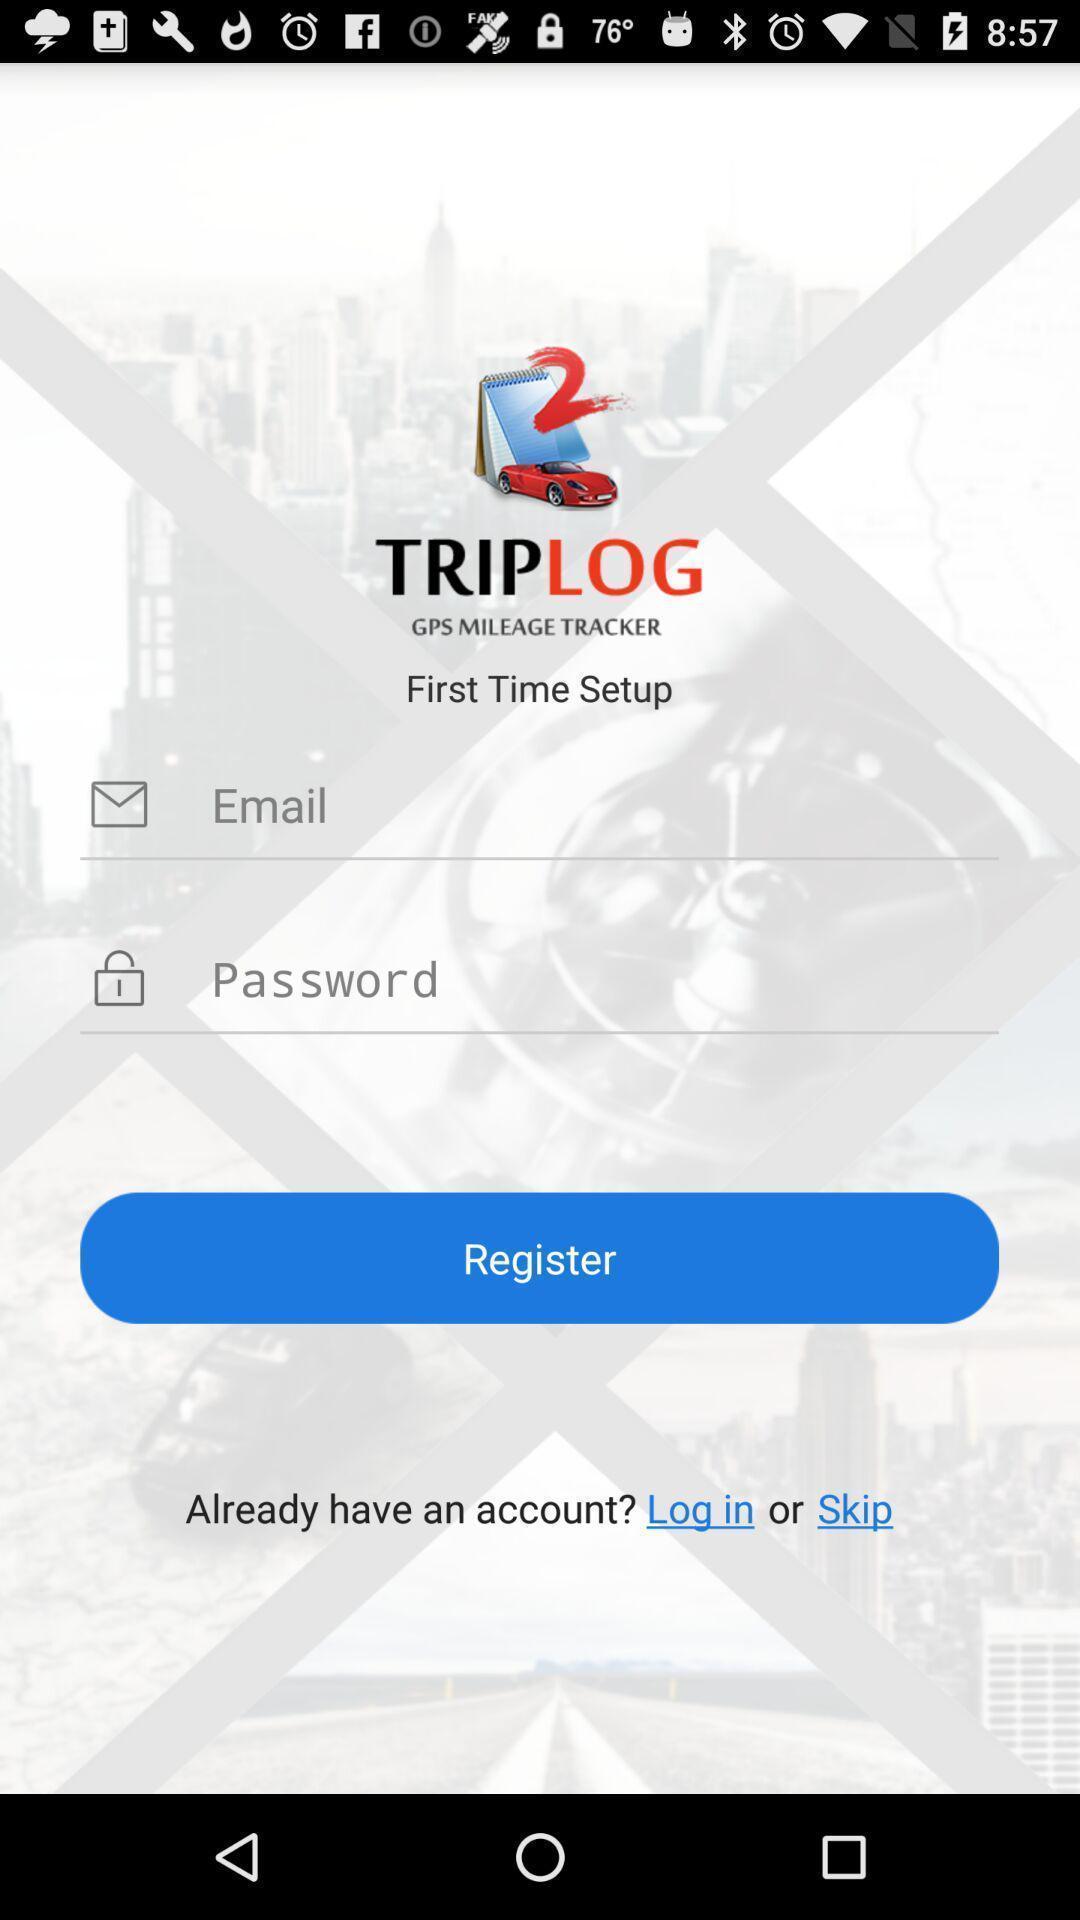Give me a narrative description of this picture. Registration page is available for the app. 